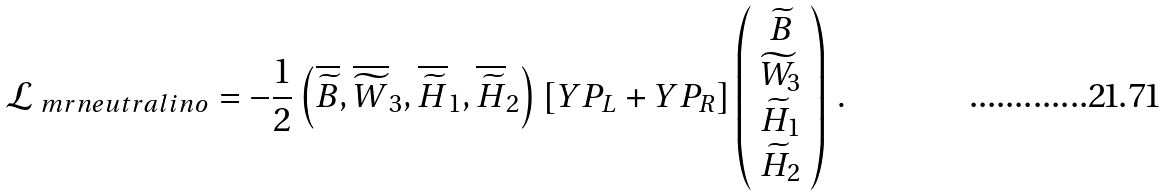Convert formula to latex. <formula><loc_0><loc_0><loc_500><loc_500>\mathcal { L } _ { \ m r { n e u t r a l i n o } } = - \frac { 1 } { 2 } \left ( \overline { \widetilde { B } } , \overline { \widetilde { W } } _ { 3 } , \overline { \widetilde { H } } _ { 1 } , \overline { \widetilde { H } } _ { 2 } \right ) \left [ Y P _ { L } + Y P _ { R } \right ] \left ( \begin{array} { c } \widetilde { B } \\ \widetilde { W } _ { 3 } \\ \widetilde { H } _ { 1 } \\ \widetilde { H } _ { 2 } \end{array} \right ) \, .</formula> 